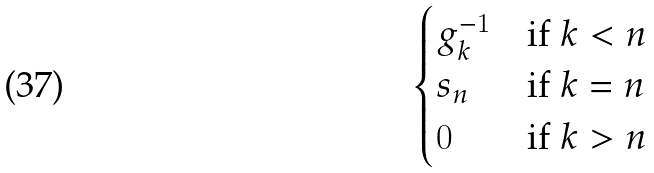Convert formula to latex. <formula><loc_0><loc_0><loc_500><loc_500>\begin{cases} g _ { k } ^ { - 1 } & \text {if $k<n$} \\ s _ { n } & \text {if $k=n$} \\ 0 & \text {if $k>n$} \end{cases}</formula> 